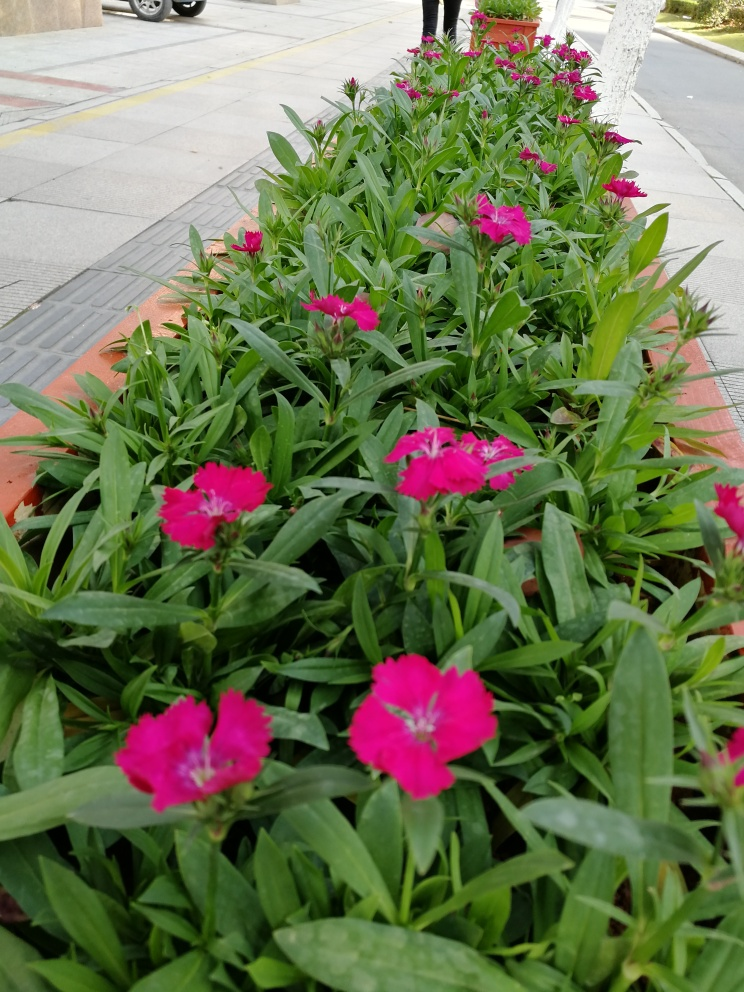Can you tell me about the setting of this image? This image shows a row of pink flowers planted in a planter along a sidewalk. It’s an urban environment as indicated by the sidewalk tiles, curb, and the presence of a vehicle in the background. It's a space likely designed to add aesthetic appeal to a city area. 